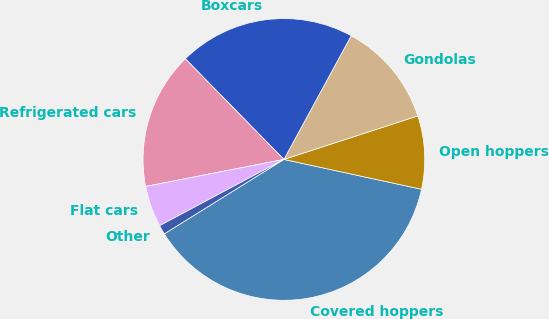Convert chart to OTSL. <chart><loc_0><loc_0><loc_500><loc_500><pie_chart><fcel>Covered hoppers<fcel>Open hoppers<fcel>Gondolas<fcel>Boxcars<fcel>Refrigerated cars<fcel>Flat cars<fcel>Other<nl><fcel>37.75%<fcel>8.4%<fcel>12.07%<fcel>20.27%<fcel>15.74%<fcel>4.73%<fcel>1.06%<nl></chart> 